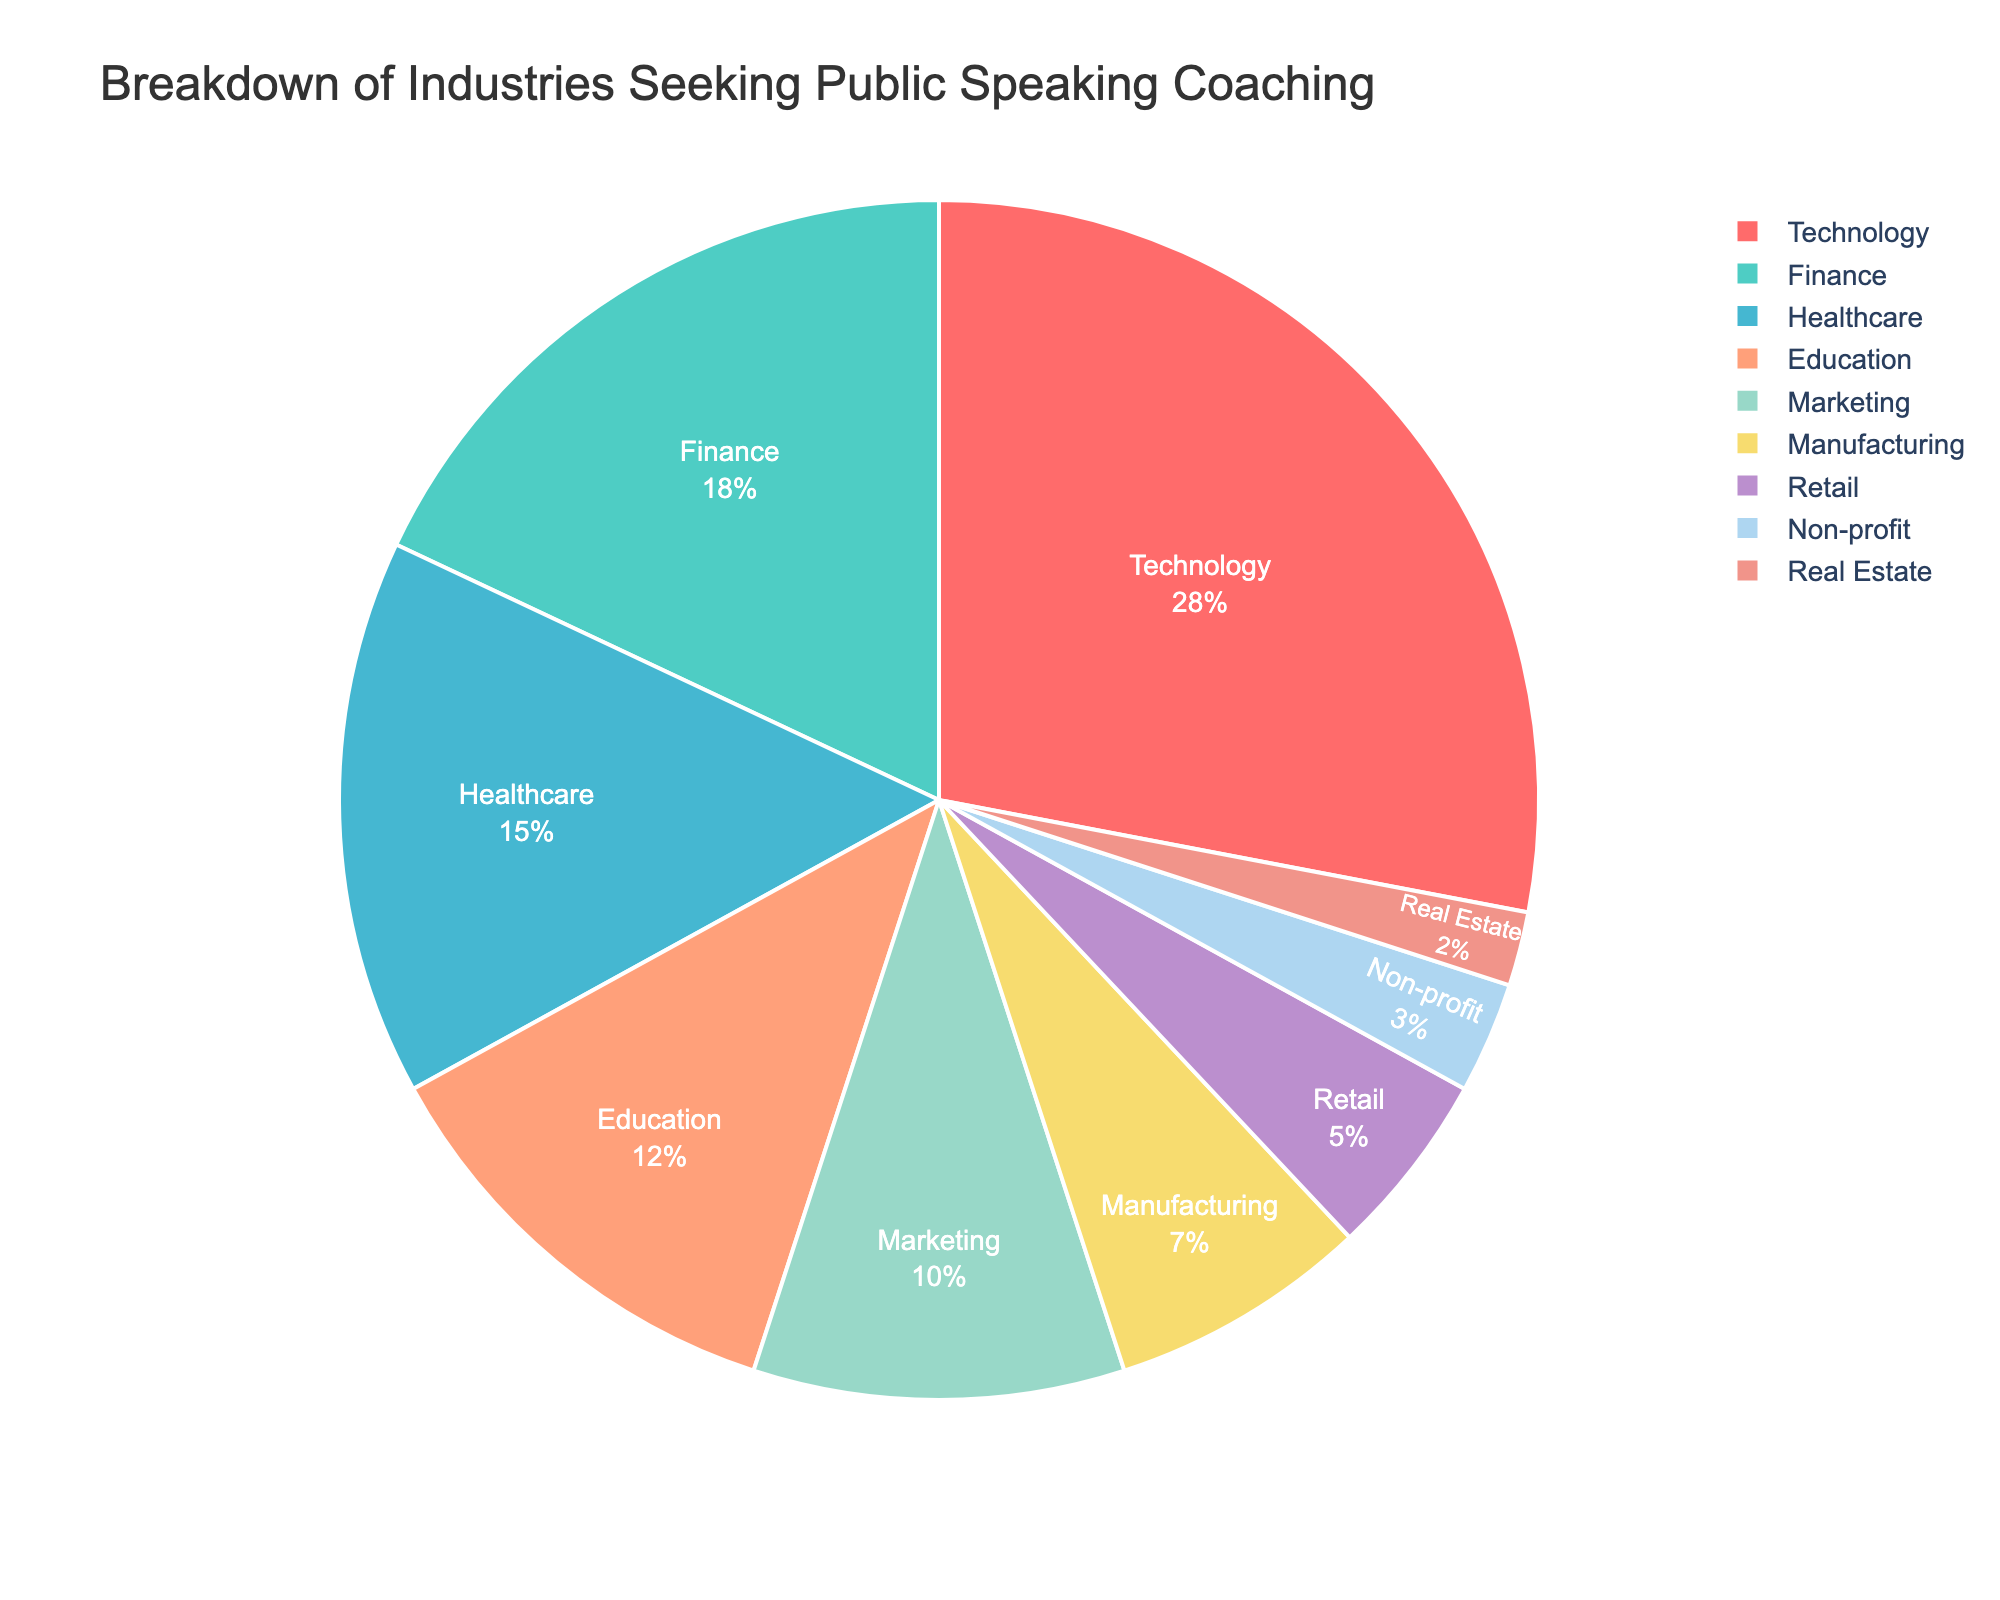What percentage of industries seeking public speaking coaching comes from the Healthcare and Education sectors combined? To find the combined percentage, add the percentages of Healthcare and Education sectors: 15% (Healthcare) + 12% (Education) = 27%.
Answer: 27% Which industry has the highest percentage of professionals seeking public speaking coaching? By comparing the percentages of all industries, the Technology sector has the highest percentage at 28%.
Answer: Technology What is the difference in the percentage of professionals seeking public speaking coaching between the Technology and Retail sectors? Subtract the percentage of the Retail sector from the Technology sector: 28% (Technology) - 5% (Retail) = 23%.
Answer: 23% Are there more professionals from the Finance or Marketing sectors seeking public speaking coaching? By comparing the percentages, the Finance sector has 18% while the Marketing sector has 10%. Hence, the Finance sector has more professionals.
Answer: Finance Which sector has the smallest percentage of professionals seeking public speaking coaching? By looking at the percentages, the Real Estate sector has the smallest percentage at 2%.
Answer: Real Estate How much more percentage does the Technology sector have compared to the Non-profit sector? Subtract the percentage of the Non-profit sector from the Technology sector: 28% (Technology) - 3% (Non-profit) = 25%.
Answer: 25% What is the total percentage of industries seeking public speaking coaching from the Manufacturing, Retail, and Non-profit sectors combined? Add the percentages of the Manufacturing, Retail, and Non-profit sectors: 7% (Manufacturing) + 5% (Retail) + 3% (Non-profit) = 15%.
Answer: 15% Among the listed sectors, which color represents the Finance sector in the pie chart? By examining the chart legend and corresponding sectors, the Finance sector is represented by the color cyan.
Answer: cyan Is the percentage of professionals seeking public speaking coaching in the Healthcare sector greater than those in the Education and Retail sectors combined? First, find the sum of percentages for Education and Retail: 12% (Education) + 5% (Retail) = 17%. Then compare it with Healthcare: 15% (Healthcare) < 17% (Education + Retail).
Answer: No 